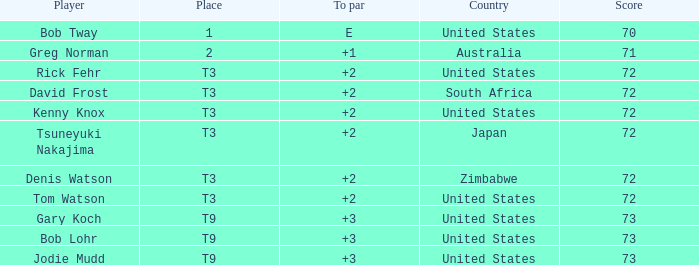What is the low score for TO par +2 in japan? 72.0. 